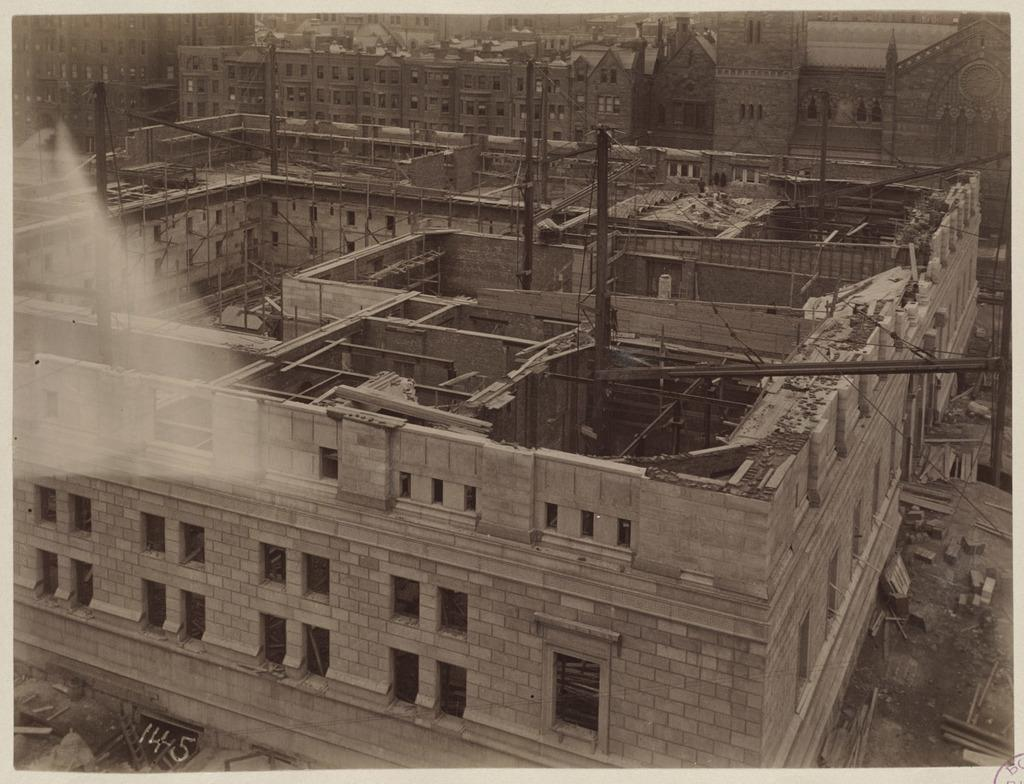What type of construction is taking place in the image? There are buildings under construction in the image. What can be seen in the image besides the buildings under construction? There are black color rods and stones visible at the bottom of the image. What type of business is being conducted in the image? There is no indication of a business being conducted in the image; it primarily shows buildings under construction. 